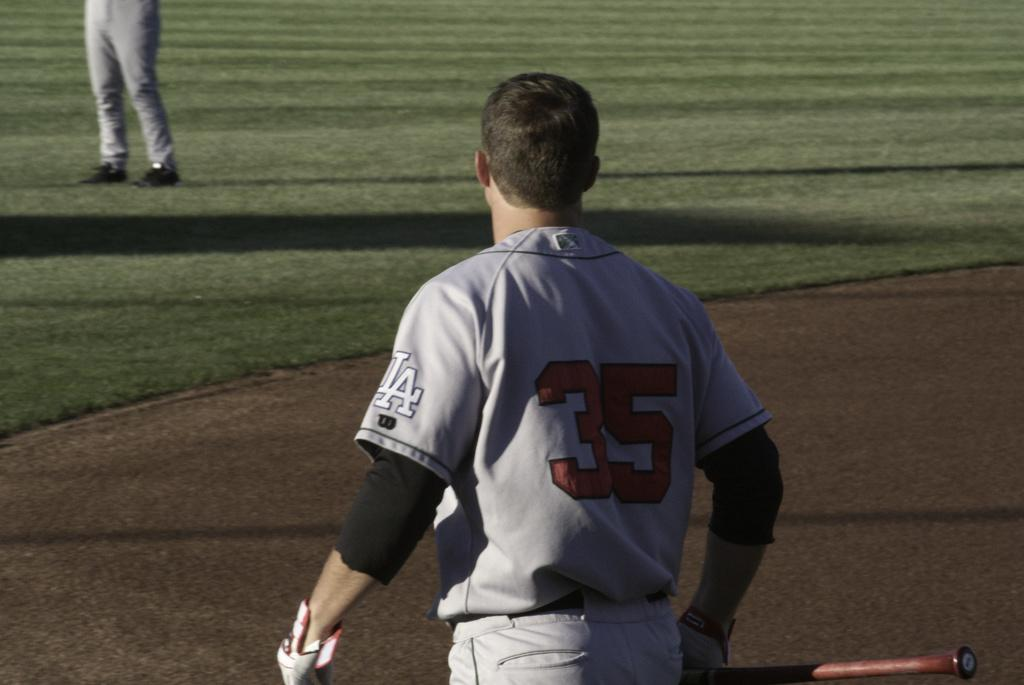What can be seen in the image? There is a person in the image. What is the person holding? The person is holding an object. What protective clothing is the person wearing? The person is wearing gloves. What type of surface is visible in the image? There is ground visible in the image. What type of vegetation can be seen in the image? There is grass in the image. Can you describe the person's legs in the image? There are person's legs visible in the background of the image. What type of property does the person own in the image? There is no information about property ownership in the image. What nerve is the person stimulating with the object they are holding? There is no indication of nerve stimulation in the image. 